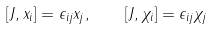<formula> <loc_0><loc_0><loc_500><loc_500>[ J , x _ { i } ] = \epsilon _ { i j } x _ { j } , \quad [ J , \chi _ { i } ] = \epsilon _ { i j } \chi _ { j }</formula> 